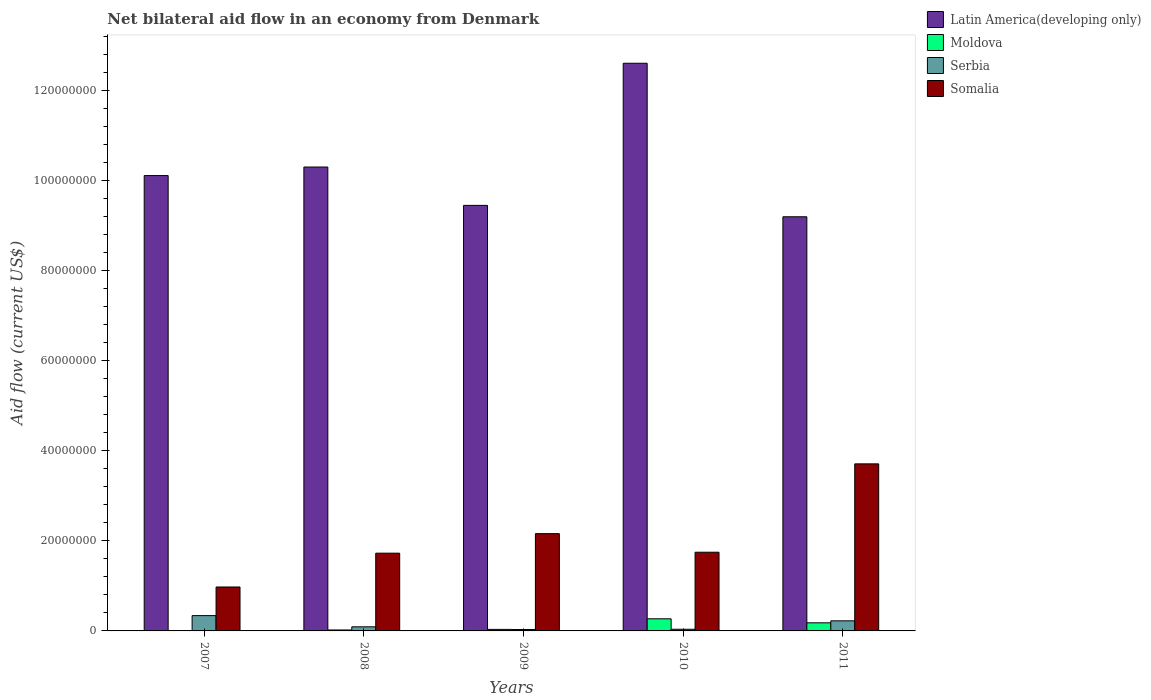How many different coloured bars are there?
Give a very brief answer. 4. How many bars are there on the 3rd tick from the left?
Offer a very short reply. 4. What is the net bilateral aid flow in Latin America(developing only) in 2007?
Provide a succinct answer. 1.01e+08. Across all years, what is the maximum net bilateral aid flow in Moldova?
Ensure brevity in your answer.  2.69e+06. Across all years, what is the minimum net bilateral aid flow in Somalia?
Provide a short and direct response. 9.76e+06. In which year was the net bilateral aid flow in Latin America(developing only) minimum?
Your response must be concise. 2011. What is the total net bilateral aid flow in Serbia in the graph?
Make the answer very short. 7.23e+06. What is the difference between the net bilateral aid flow in Somalia in 2008 and that in 2010?
Your response must be concise. -2.10e+05. What is the difference between the net bilateral aid flow in Somalia in 2008 and the net bilateral aid flow in Moldova in 2010?
Your answer should be very brief. 1.46e+07. What is the average net bilateral aid flow in Latin America(developing only) per year?
Offer a very short reply. 1.03e+08. In the year 2010, what is the difference between the net bilateral aid flow in Somalia and net bilateral aid flow in Moldova?
Provide a short and direct response. 1.48e+07. In how many years, is the net bilateral aid flow in Latin America(developing only) greater than 20000000 US$?
Make the answer very short. 5. What is the ratio of the net bilateral aid flow in Moldova in 2009 to that in 2011?
Your answer should be compact. 0.19. Is the net bilateral aid flow in Moldova in 2009 less than that in 2011?
Your answer should be very brief. Yes. What is the difference between the highest and the second highest net bilateral aid flow in Moldova?
Your answer should be compact. 8.90e+05. What is the difference between the highest and the lowest net bilateral aid flow in Somalia?
Provide a succinct answer. 2.74e+07. Is it the case that in every year, the sum of the net bilateral aid flow in Somalia and net bilateral aid flow in Serbia is greater than the sum of net bilateral aid flow in Latin America(developing only) and net bilateral aid flow in Moldova?
Your answer should be compact. Yes. What does the 3rd bar from the left in 2011 represents?
Give a very brief answer. Serbia. What does the 4th bar from the right in 2009 represents?
Your answer should be compact. Latin America(developing only). How many years are there in the graph?
Your response must be concise. 5. What is the difference between two consecutive major ticks on the Y-axis?
Offer a very short reply. 2.00e+07. Are the values on the major ticks of Y-axis written in scientific E-notation?
Make the answer very short. No. Does the graph contain any zero values?
Your answer should be compact. No. How are the legend labels stacked?
Your answer should be compact. Vertical. What is the title of the graph?
Provide a succinct answer. Net bilateral aid flow in an economy from Denmark. What is the label or title of the Y-axis?
Give a very brief answer. Aid flow (current US$). What is the Aid flow (current US$) of Latin America(developing only) in 2007?
Your answer should be compact. 1.01e+08. What is the Aid flow (current US$) in Serbia in 2007?
Provide a short and direct response. 3.40e+06. What is the Aid flow (current US$) in Somalia in 2007?
Offer a very short reply. 9.76e+06. What is the Aid flow (current US$) of Latin America(developing only) in 2008?
Provide a succinct answer. 1.03e+08. What is the Aid flow (current US$) of Moldova in 2008?
Ensure brevity in your answer.  2.10e+05. What is the Aid flow (current US$) in Serbia in 2008?
Your answer should be compact. 9.10e+05. What is the Aid flow (current US$) of Somalia in 2008?
Ensure brevity in your answer.  1.73e+07. What is the Aid flow (current US$) in Latin America(developing only) in 2009?
Your answer should be compact. 9.45e+07. What is the Aid flow (current US$) of Serbia in 2009?
Your answer should be compact. 3.10e+05. What is the Aid flow (current US$) in Somalia in 2009?
Your response must be concise. 2.16e+07. What is the Aid flow (current US$) of Latin America(developing only) in 2010?
Offer a very short reply. 1.26e+08. What is the Aid flow (current US$) in Moldova in 2010?
Provide a short and direct response. 2.69e+06. What is the Aid flow (current US$) of Serbia in 2010?
Give a very brief answer. 3.70e+05. What is the Aid flow (current US$) of Somalia in 2010?
Provide a short and direct response. 1.75e+07. What is the Aid flow (current US$) in Latin America(developing only) in 2011?
Provide a succinct answer. 9.20e+07. What is the Aid flow (current US$) of Moldova in 2011?
Your answer should be compact. 1.80e+06. What is the Aid flow (current US$) of Serbia in 2011?
Offer a terse response. 2.24e+06. What is the Aid flow (current US$) of Somalia in 2011?
Your answer should be very brief. 3.71e+07. Across all years, what is the maximum Aid flow (current US$) of Latin America(developing only)?
Provide a short and direct response. 1.26e+08. Across all years, what is the maximum Aid flow (current US$) of Moldova?
Offer a terse response. 2.69e+06. Across all years, what is the maximum Aid flow (current US$) in Serbia?
Your response must be concise. 3.40e+06. Across all years, what is the maximum Aid flow (current US$) in Somalia?
Your answer should be compact. 3.71e+07. Across all years, what is the minimum Aid flow (current US$) of Latin America(developing only)?
Make the answer very short. 9.20e+07. Across all years, what is the minimum Aid flow (current US$) in Serbia?
Offer a terse response. 3.10e+05. Across all years, what is the minimum Aid flow (current US$) in Somalia?
Your answer should be compact. 9.76e+06. What is the total Aid flow (current US$) in Latin America(developing only) in the graph?
Your response must be concise. 5.17e+08. What is the total Aid flow (current US$) of Moldova in the graph?
Offer a very short reply. 5.12e+06. What is the total Aid flow (current US$) of Serbia in the graph?
Provide a short and direct response. 7.23e+06. What is the total Aid flow (current US$) in Somalia in the graph?
Keep it short and to the point. 1.03e+08. What is the difference between the Aid flow (current US$) of Latin America(developing only) in 2007 and that in 2008?
Offer a very short reply. -1.90e+06. What is the difference between the Aid flow (current US$) in Moldova in 2007 and that in 2008?
Make the answer very short. -1.30e+05. What is the difference between the Aid flow (current US$) in Serbia in 2007 and that in 2008?
Give a very brief answer. 2.49e+06. What is the difference between the Aid flow (current US$) of Somalia in 2007 and that in 2008?
Make the answer very short. -7.51e+06. What is the difference between the Aid flow (current US$) in Latin America(developing only) in 2007 and that in 2009?
Provide a succinct answer. 6.62e+06. What is the difference between the Aid flow (current US$) in Serbia in 2007 and that in 2009?
Make the answer very short. 3.09e+06. What is the difference between the Aid flow (current US$) in Somalia in 2007 and that in 2009?
Give a very brief answer. -1.18e+07. What is the difference between the Aid flow (current US$) of Latin America(developing only) in 2007 and that in 2010?
Make the answer very short. -2.50e+07. What is the difference between the Aid flow (current US$) in Moldova in 2007 and that in 2010?
Your answer should be very brief. -2.61e+06. What is the difference between the Aid flow (current US$) in Serbia in 2007 and that in 2010?
Your answer should be compact. 3.03e+06. What is the difference between the Aid flow (current US$) of Somalia in 2007 and that in 2010?
Give a very brief answer. -7.72e+06. What is the difference between the Aid flow (current US$) of Latin America(developing only) in 2007 and that in 2011?
Your answer should be very brief. 9.15e+06. What is the difference between the Aid flow (current US$) in Moldova in 2007 and that in 2011?
Give a very brief answer. -1.72e+06. What is the difference between the Aid flow (current US$) of Serbia in 2007 and that in 2011?
Give a very brief answer. 1.16e+06. What is the difference between the Aid flow (current US$) of Somalia in 2007 and that in 2011?
Make the answer very short. -2.74e+07. What is the difference between the Aid flow (current US$) in Latin America(developing only) in 2008 and that in 2009?
Give a very brief answer. 8.52e+06. What is the difference between the Aid flow (current US$) in Somalia in 2008 and that in 2009?
Your answer should be compact. -4.34e+06. What is the difference between the Aid flow (current US$) of Latin America(developing only) in 2008 and that in 2010?
Make the answer very short. -2.30e+07. What is the difference between the Aid flow (current US$) in Moldova in 2008 and that in 2010?
Ensure brevity in your answer.  -2.48e+06. What is the difference between the Aid flow (current US$) of Serbia in 2008 and that in 2010?
Keep it short and to the point. 5.40e+05. What is the difference between the Aid flow (current US$) in Latin America(developing only) in 2008 and that in 2011?
Provide a succinct answer. 1.10e+07. What is the difference between the Aid flow (current US$) of Moldova in 2008 and that in 2011?
Offer a very short reply. -1.59e+06. What is the difference between the Aid flow (current US$) in Serbia in 2008 and that in 2011?
Ensure brevity in your answer.  -1.33e+06. What is the difference between the Aid flow (current US$) of Somalia in 2008 and that in 2011?
Offer a very short reply. -1.98e+07. What is the difference between the Aid flow (current US$) of Latin America(developing only) in 2009 and that in 2010?
Your answer should be compact. -3.16e+07. What is the difference between the Aid flow (current US$) in Moldova in 2009 and that in 2010?
Provide a short and direct response. -2.35e+06. What is the difference between the Aid flow (current US$) of Somalia in 2009 and that in 2010?
Ensure brevity in your answer.  4.13e+06. What is the difference between the Aid flow (current US$) in Latin America(developing only) in 2009 and that in 2011?
Your response must be concise. 2.53e+06. What is the difference between the Aid flow (current US$) in Moldova in 2009 and that in 2011?
Your answer should be very brief. -1.46e+06. What is the difference between the Aid flow (current US$) of Serbia in 2009 and that in 2011?
Your answer should be compact. -1.93e+06. What is the difference between the Aid flow (current US$) in Somalia in 2009 and that in 2011?
Your answer should be very brief. -1.55e+07. What is the difference between the Aid flow (current US$) of Latin America(developing only) in 2010 and that in 2011?
Your answer should be very brief. 3.41e+07. What is the difference between the Aid flow (current US$) of Moldova in 2010 and that in 2011?
Your answer should be compact. 8.90e+05. What is the difference between the Aid flow (current US$) in Serbia in 2010 and that in 2011?
Make the answer very short. -1.87e+06. What is the difference between the Aid flow (current US$) in Somalia in 2010 and that in 2011?
Provide a succinct answer. -1.96e+07. What is the difference between the Aid flow (current US$) of Latin America(developing only) in 2007 and the Aid flow (current US$) of Moldova in 2008?
Offer a terse response. 1.01e+08. What is the difference between the Aid flow (current US$) of Latin America(developing only) in 2007 and the Aid flow (current US$) of Serbia in 2008?
Your response must be concise. 1.00e+08. What is the difference between the Aid flow (current US$) of Latin America(developing only) in 2007 and the Aid flow (current US$) of Somalia in 2008?
Ensure brevity in your answer.  8.39e+07. What is the difference between the Aid flow (current US$) of Moldova in 2007 and the Aid flow (current US$) of Serbia in 2008?
Provide a short and direct response. -8.30e+05. What is the difference between the Aid flow (current US$) in Moldova in 2007 and the Aid flow (current US$) in Somalia in 2008?
Ensure brevity in your answer.  -1.72e+07. What is the difference between the Aid flow (current US$) in Serbia in 2007 and the Aid flow (current US$) in Somalia in 2008?
Your response must be concise. -1.39e+07. What is the difference between the Aid flow (current US$) of Latin America(developing only) in 2007 and the Aid flow (current US$) of Moldova in 2009?
Offer a very short reply. 1.01e+08. What is the difference between the Aid flow (current US$) in Latin America(developing only) in 2007 and the Aid flow (current US$) in Serbia in 2009?
Your answer should be very brief. 1.01e+08. What is the difference between the Aid flow (current US$) of Latin America(developing only) in 2007 and the Aid flow (current US$) of Somalia in 2009?
Provide a succinct answer. 7.95e+07. What is the difference between the Aid flow (current US$) in Moldova in 2007 and the Aid flow (current US$) in Serbia in 2009?
Offer a very short reply. -2.30e+05. What is the difference between the Aid flow (current US$) in Moldova in 2007 and the Aid flow (current US$) in Somalia in 2009?
Provide a short and direct response. -2.15e+07. What is the difference between the Aid flow (current US$) of Serbia in 2007 and the Aid flow (current US$) of Somalia in 2009?
Offer a very short reply. -1.82e+07. What is the difference between the Aid flow (current US$) in Latin America(developing only) in 2007 and the Aid flow (current US$) in Moldova in 2010?
Keep it short and to the point. 9.85e+07. What is the difference between the Aid flow (current US$) in Latin America(developing only) in 2007 and the Aid flow (current US$) in Serbia in 2010?
Make the answer very short. 1.01e+08. What is the difference between the Aid flow (current US$) of Latin America(developing only) in 2007 and the Aid flow (current US$) of Somalia in 2010?
Give a very brief answer. 8.37e+07. What is the difference between the Aid flow (current US$) in Moldova in 2007 and the Aid flow (current US$) in Somalia in 2010?
Keep it short and to the point. -1.74e+07. What is the difference between the Aid flow (current US$) in Serbia in 2007 and the Aid flow (current US$) in Somalia in 2010?
Your answer should be very brief. -1.41e+07. What is the difference between the Aid flow (current US$) of Latin America(developing only) in 2007 and the Aid flow (current US$) of Moldova in 2011?
Your response must be concise. 9.94e+07. What is the difference between the Aid flow (current US$) of Latin America(developing only) in 2007 and the Aid flow (current US$) of Serbia in 2011?
Make the answer very short. 9.89e+07. What is the difference between the Aid flow (current US$) in Latin America(developing only) in 2007 and the Aid flow (current US$) in Somalia in 2011?
Your answer should be very brief. 6.40e+07. What is the difference between the Aid flow (current US$) of Moldova in 2007 and the Aid flow (current US$) of Serbia in 2011?
Offer a very short reply. -2.16e+06. What is the difference between the Aid flow (current US$) in Moldova in 2007 and the Aid flow (current US$) in Somalia in 2011?
Provide a succinct answer. -3.70e+07. What is the difference between the Aid flow (current US$) in Serbia in 2007 and the Aid flow (current US$) in Somalia in 2011?
Provide a short and direct response. -3.37e+07. What is the difference between the Aid flow (current US$) of Latin America(developing only) in 2008 and the Aid flow (current US$) of Moldova in 2009?
Your answer should be compact. 1.03e+08. What is the difference between the Aid flow (current US$) of Latin America(developing only) in 2008 and the Aid flow (current US$) of Serbia in 2009?
Provide a short and direct response. 1.03e+08. What is the difference between the Aid flow (current US$) of Latin America(developing only) in 2008 and the Aid flow (current US$) of Somalia in 2009?
Provide a succinct answer. 8.14e+07. What is the difference between the Aid flow (current US$) in Moldova in 2008 and the Aid flow (current US$) in Serbia in 2009?
Give a very brief answer. -1.00e+05. What is the difference between the Aid flow (current US$) of Moldova in 2008 and the Aid flow (current US$) of Somalia in 2009?
Your answer should be very brief. -2.14e+07. What is the difference between the Aid flow (current US$) of Serbia in 2008 and the Aid flow (current US$) of Somalia in 2009?
Ensure brevity in your answer.  -2.07e+07. What is the difference between the Aid flow (current US$) in Latin America(developing only) in 2008 and the Aid flow (current US$) in Moldova in 2010?
Keep it short and to the point. 1.00e+08. What is the difference between the Aid flow (current US$) of Latin America(developing only) in 2008 and the Aid flow (current US$) of Serbia in 2010?
Make the answer very short. 1.03e+08. What is the difference between the Aid flow (current US$) of Latin America(developing only) in 2008 and the Aid flow (current US$) of Somalia in 2010?
Your response must be concise. 8.56e+07. What is the difference between the Aid flow (current US$) of Moldova in 2008 and the Aid flow (current US$) of Serbia in 2010?
Your answer should be compact. -1.60e+05. What is the difference between the Aid flow (current US$) in Moldova in 2008 and the Aid flow (current US$) in Somalia in 2010?
Give a very brief answer. -1.73e+07. What is the difference between the Aid flow (current US$) of Serbia in 2008 and the Aid flow (current US$) of Somalia in 2010?
Give a very brief answer. -1.66e+07. What is the difference between the Aid flow (current US$) of Latin America(developing only) in 2008 and the Aid flow (current US$) of Moldova in 2011?
Ensure brevity in your answer.  1.01e+08. What is the difference between the Aid flow (current US$) of Latin America(developing only) in 2008 and the Aid flow (current US$) of Serbia in 2011?
Your answer should be very brief. 1.01e+08. What is the difference between the Aid flow (current US$) of Latin America(developing only) in 2008 and the Aid flow (current US$) of Somalia in 2011?
Keep it short and to the point. 6.59e+07. What is the difference between the Aid flow (current US$) in Moldova in 2008 and the Aid flow (current US$) in Serbia in 2011?
Your answer should be compact. -2.03e+06. What is the difference between the Aid flow (current US$) of Moldova in 2008 and the Aid flow (current US$) of Somalia in 2011?
Provide a short and direct response. -3.69e+07. What is the difference between the Aid flow (current US$) of Serbia in 2008 and the Aid flow (current US$) of Somalia in 2011?
Your answer should be very brief. -3.62e+07. What is the difference between the Aid flow (current US$) in Latin America(developing only) in 2009 and the Aid flow (current US$) in Moldova in 2010?
Your answer should be compact. 9.18e+07. What is the difference between the Aid flow (current US$) of Latin America(developing only) in 2009 and the Aid flow (current US$) of Serbia in 2010?
Give a very brief answer. 9.42e+07. What is the difference between the Aid flow (current US$) in Latin America(developing only) in 2009 and the Aid flow (current US$) in Somalia in 2010?
Your response must be concise. 7.70e+07. What is the difference between the Aid flow (current US$) of Moldova in 2009 and the Aid flow (current US$) of Somalia in 2010?
Keep it short and to the point. -1.71e+07. What is the difference between the Aid flow (current US$) of Serbia in 2009 and the Aid flow (current US$) of Somalia in 2010?
Keep it short and to the point. -1.72e+07. What is the difference between the Aid flow (current US$) of Latin America(developing only) in 2009 and the Aid flow (current US$) of Moldova in 2011?
Keep it short and to the point. 9.27e+07. What is the difference between the Aid flow (current US$) of Latin America(developing only) in 2009 and the Aid flow (current US$) of Serbia in 2011?
Offer a terse response. 9.23e+07. What is the difference between the Aid flow (current US$) of Latin America(developing only) in 2009 and the Aid flow (current US$) of Somalia in 2011?
Your answer should be very brief. 5.74e+07. What is the difference between the Aid flow (current US$) of Moldova in 2009 and the Aid flow (current US$) of Serbia in 2011?
Offer a very short reply. -1.90e+06. What is the difference between the Aid flow (current US$) in Moldova in 2009 and the Aid flow (current US$) in Somalia in 2011?
Your response must be concise. -3.68e+07. What is the difference between the Aid flow (current US$) in Serbia in 2009 and the Aid flow (current US$) in Somalia in 2011?
Your answer should be very brief. -3.68e+07. What is the difference between the Aid flow (current US$) of Latin America(developing only) in 2010 and the Aid flow (current US$) of Moldova in 2011?
Your answer should be compact. 1.24e+08. What is the difference between the Aid flow (current US$) of Latin America(developing only) in 2010 and the Aid flow (current US$) of Serbia in 2011?
Your response must be concise. 1.24e+08. What is the difference between the Aid flow (current US$) of Latin America(developing only) in 2010 and the Aid flow (current US$) of Somalia in 2011?
Your answer should be compact. 8.90e+07. What is the difference between the Aid flow (current US$) in Moldova in 2010 and the Aid flow (current US$) in Serbia in 2011?
Your response must be concise. 4.50e+05. What is the difference between the Aid flow (current US$) of Moldova in 2010 and the Aid flow (current US$) of Somalia in 2011?
Ensure brevity in your answer.  -3.44e+07. What is the difference between the Aid flow (current US$) of Serbia in 2010 and the Aid flow (current US$) of Somalia in 2011?
Offer a very short reply. -3.67e+07. What is the average Aid flow (current US$) of Latin America(developing only) per year?
Your response must be concise. 1.03e+08. What is the average Aid flow (current US$) in Moldova per year?
Offer a very short reply. 1.02e+06. What is the average Aid flow (current US$) of Serbia per year?
Provide a succinct answer. 1.45e+06. What is the average Aid flow (current US$) of Somalia per year?
Ensure brevity in your answer.  2.06e+07. In the year 2007, what is the difference between the Aid flow (current US$) in Latin America(developing only) and Aid flow (current US$) in Moldova?
Provide a short and direct response. 1.01e+08. In the year 2007, what is the difference between the Aid flow (current US$) in Latin America(developing only) and Aid flow (current US$) in Serbia?
Make the answer very short. 9.78e+07. In the year 2007, what is the difference between the Aid flow (current US$) of Latin America(developing only) and Aid flow (current US$) of Somalia?
Your answer should be very brief. 9.14e+07. In the year 2007, what is the difference between the Aid flow (current US$) in Moldova and Aid flow (current US$) in Serbia?
Ensure brevity in your answer.  -3.32e+06. In the year 2007, what is the difference between the Aid flow (current US$) of Moldova and Aid flow (current US$) of Somalia?
Ensure brevity in your answer.  -9.68e+06. In the year 2007, what is the difference between the Aid flow (current US$) of Serbia and Aid flow (current US$) of Somalia?
Make the answer very short. -6.36e+06. In the year 2008, what is the difference between the Aid flow (current US$) of Latin America(developing only) and Aid flow (current US$) of Moldova?
Provide a short and direct response. 1.03e+08. In the year 2008, what is the difference between the Aid flow (current US$) in Latin America(developing only) and Aid flow (current US$) in Serbia?
Offer a very short reply. 1.02e+08. In the year 2008, what is the difference between the Aid flow (current US$) in Latin America(developing only) and Aid flow (current US$) in Somalia?
Your answer should be very brief. 8.58e+07. In the year 2008, what is the difference between the Aid flow (current US$) of Moldova and Aid flow (current US$) of Serbia?
Give a very brief answer. -7.00e+05. In the year 2008, what is the difference between the Aid flow (current US$) in Moldova and Aid flow (current US$) in Somalia?
Keep it short and to the point. -1.71e+07. In the year 2008, what is the difference between the Aid flow (current US$) of Serbia and Aid flow (current US$) of Somalia?
Your response must be concise. -1.64e+07. In the year 2009, what is the difference between the Aid flow (current US$) of Latin America(developing only) and Aid flow (current US$) of Moldova?
Offer a very short reply. 9.42e+07. In the year 2009, what is the difference between the Aid flow (current US$) of Latin America(developing only) and Aid flow (current US$) of Serbia?
Give a very brief answer. 9.42e+07. In the year 2009, what is the difference between the Aid flow (current US$) of Latin America(developing only) and Aid flow (current US$) of Somalia?
Provide a succinct answer. 7.29e+07. In the year 2009, what is the difference between the Aid flow (current US$) in Moldova and Aid flow (current US$) in Serbia?
Your answer should be very brief. 3.00e+04. In the year 2009, what is the difference between the Aid flow (current US$) in Moldova and Aid flow (current US$) in Somalia?
Provide a succinct answer. -2.13e+07. In the year 2009, what is the difference between the Aid flow (current US$) in Serbia and Aid flow (current US$) in Somalia?
Offer a very short reply. -2.13e+07. In the year 2010, what is the difference between the Aid flow (current US$) in Latin America(developing only) and Aid flow (current US$) in Moldova?
Your answer should be compact. 1.23e+08. In the year 2010, what is the difference between the Aid flow (current US$) in Latin America(developing only) and Aid flow (current US$) in Serbia?
Make the answer very short. 1.26e+08. In the year 2010, what is the difference between the Aid flow (current US$) of Latin America(developing only) and Aid flow (current US$) of Somalia?
Offer a very short reply. 1.09e+08. In the year 2010, what is the difference between the Aid flow (current US$) in Moldova and Aid flow (current US$) in Serbia?
Offer a terse response. 2.32e+06. In the year 2010, what is the difference between the Aid flow (current US$) of Moldova and Aid flow (current US$) of Somalia?
Ensure brevity in your answer.  -1.48e+07. In the year 2010, what is the difference between the Aid flow (current US$) of Serbia and Aid flow (current US$) of Somalia?
Make the answer very short. -1.71e+07. In the year 2011, what is the difference between the Aid flow (current US$) in Latin America(developing only) and Aid flow (current US$) in Moldova?
Keep it short and to the point. 9.02e+07. In the year 2011, what is the difference between the Aid flow (current US$) of Latin America(developing only) and Aid flow (current US$) of Serbia?
Make the answer very short. 8.98e+07. In the year 2011, what is the difference between the Aid flow (current US$) in Latin America(developing only) and Aid flow (current US$) in Somalia?
Your answer should be compact. 5.49e+07. In the year 2011, what is the difference between the Aid flow (current US$) in Moldova and Aid flow (current US$) in Serbia?
Provide a succinct answer. -4.40e+05. In the year 2011, what is the difference between the Aid flow (current US$) of Moldova and Aid flow (current US$) of Somalia?
Keep it short and to the point. -3.53e+07. In the year 2011, what is the difference between the Aid flow (current US$) of Serbia and Aid flow (current US$) of Somalia?
Offer a very short reply. -3.49e+07. What is the ratio of the Aid flow (current US$) of Latin America(developing only) in 2007 to that in 2008?
Give a very brief answer. 0.98. What is the ratio of the Aid flow (current US$) of Moldova in 2007 to that in 2008?
Offer a terse response. 0.38. What is the ratio of the Aid flow (current US$) in Serbia in 2007 to that in 2008?
Offer a terse response. 3.74. What is the ratio of the Aid flow (current US$) in Somalia in 2007 to that in 2008?
Give a very brief answer. 0.57. What is the ratio of the Aid flow (current US$) of Latin America(developing only) in 2007 to that in 2009?
Offer a terse response. 1.07. What is the ratio of the Aid flow (current US$) of Moldova in 2007 to that in 2009?
Your answer should be compact. 0.24. What is the ratio of the Aid flow (current US$) of Serbia in 2007 to that in 2009?
Offer a very short reply. 10.97. What is the ratio of the Aid flow (current US$) of Somalia in 2007 to that in 2009?
Ensure brevity in your answer.  0.45. What is the ratio of the Aid flow (current US$) in Latin America(developing only) in 2007 to that in 2010?
Offer a terse response. 0.8. What is the ratio of the Aid flow (current US$) of Moldova in 2007 to that in 2010?
Your answer should be compact. 0.03. What is the ratio of the Aid flow (current US$) in Serbia in 2007 to that in 2010?
Keep it short and to the point. 9.19. What is the ratio of the Aid flow (current US$) of Somalia in 2007 to that in 2010?
Provide a short and direct response. 0.56. What is the ratio of the Aid flow (current US$) in Latin America(developing only) in 2007 to that in 2011?
Provide a succinct answer. 1.1. What is the ratio of the Aid flow (current US$) in Moldova in 2007 to that in 2011?
Provide a short and direct response. 0.04. What is the ratio of the Aid flow (current US$) in Serbia in 2007 to that in 2011?
Your response must be concise. 1.52. What is the ratio of the Aid flow (current US$) of Somalia in 2007 to that in 2011?
Offer a terse response. 0.26. What is the ratio of the Aid flow (current US$) in Latin America(developing only) in 2008 to that in 2009?
Ensure brevity in your answer.  1.09. What is the ratio of the Aid flow (current US$) in Moldova in 2008 to that in 2009?
Your response must be concise. 0.62. What is the ratio of the Aid flow (current US$) in Serbia in 2008 to that in 2009?
Make the answer very short. 2.94. What is the ratio of the Aid flow (current US$) of Somalia in 2008 to that in 2009?
Keep it short and to the point. 0.8. What is the ratio of the Aid flow (current US$) of Latin America(developing only) in 2008 to that in 2010?
Give a very brief answer. 0.82. What is the ratio of the Aid flow (current US$) in Moldova in 2008 to that in 2010?
Make the answer very short. 0.08. What is the ratio of the Aid flow (current US$) in Serbia in 2008 to that in 2010?
Provide a succinct answer. 2.46. What is the ratio of the Aid flow (current US$) in Latin America(developing only) in 2008 to that in 2011?
Offer a terse response. 1.12. What is the ratio of the Aid flow (current US$) in Moldova in 2008 to that in 2011?
Keep it short and to the point. 0.12. What is the ratio of the Aid flow (current US$) in Serbia in 2008 to that in 2011?
Make the answer very short. 0.41. What is the ratio of the Aid flow (current US$) in Somalia in 2008 to that in 2011?
Your answer should be very brief. 0.47. What is the ratio of the Aid flow (current US$) in Latin America(developing only) in 2009 to that in 2010?
Offer a very short reply. 0.75. What is the ratio of the Aid flow (current US$) of Moldova in 2009 to that in 2010?
Provide a succinct answer. 0.13. What is the ratio of the Aid flow (current US$) of Serbia in 2009 to that in 2010?
Provide a short and direct response. 0.84. What is the ratio of the Aid flow (current US$) in Somalia in 2009 to that in 2010?
Your response must be concise. 1.24. What is the ratio of the Aid flow (current US$) of Latin America(developing only) in 2009 to that in 2011?
Your answer should be compact. 1.03. What is the ratio of the Aid flow (current US$) in Moldova in 2009 to that in 2011?
Your response must be concise. 0.19. What is the ratio of the Aid flow (current US$) of Serbia in 2009 to that in 2011?
Offer a terse response. 0.14. What is the ratio of the Aid flow (current US$) in Somalia in 2009 to that in 2011?
Your answer should be very brief. 0.58. What is the ratio of the Aid flow (current US$) in Latin America(developing only) in 2010 to that in 2011?
Offer a very short reply. 1.37. What is the ratio of the Aid flow (current US$) in Moldova in 2010 to that in 2011?
Your answer should be compact. 1.49. What is the ratio of the Aid flow (current US$) of Serbia in 2010 to that in 2011?
Your answer should be compact. 0.17. What is the ratio of the Aid flow (current US$) of Somalia in 2010 to that in 2011?
Provide a short and direct response. 0.47. What is the difference between the highest and the second highest Aid flow (current US$) of Latin America(developing only)?
Provide a succinct answer. 2.30e+07. What is the difference between the highest and the second highest Aid flow (current US$) of Moldova?
Provide a short and direct response. 8.90e+05. What is the difference between the highest and the second highest Aid flow (current US$) of Serbia?
Offer a terse response. 1.16e+06. What is the difference between the highest and the second highest Aid flow (current US$) of Somalia?
Provide a succinct answer. 1.55e+07. What is the difference between the highest and the lowest Aid flow (current US$) in Latin America(developing only)?
Offer a very short reply. 3.41e+07. What is the difference between the highest and the lowest Aid flow (current US$) in Moldova?
Give a very brief answer. 2.61e+06. What is the difference between the highest and the lowest Aid flow (current US$) of Serbia?
Ensure brevity in your answer.  3.09e+06. What is the difference between the highest and the lowest Aid flow (current US$) of Somalia?
Ensure brevity in your answer.  2.74e+07. 